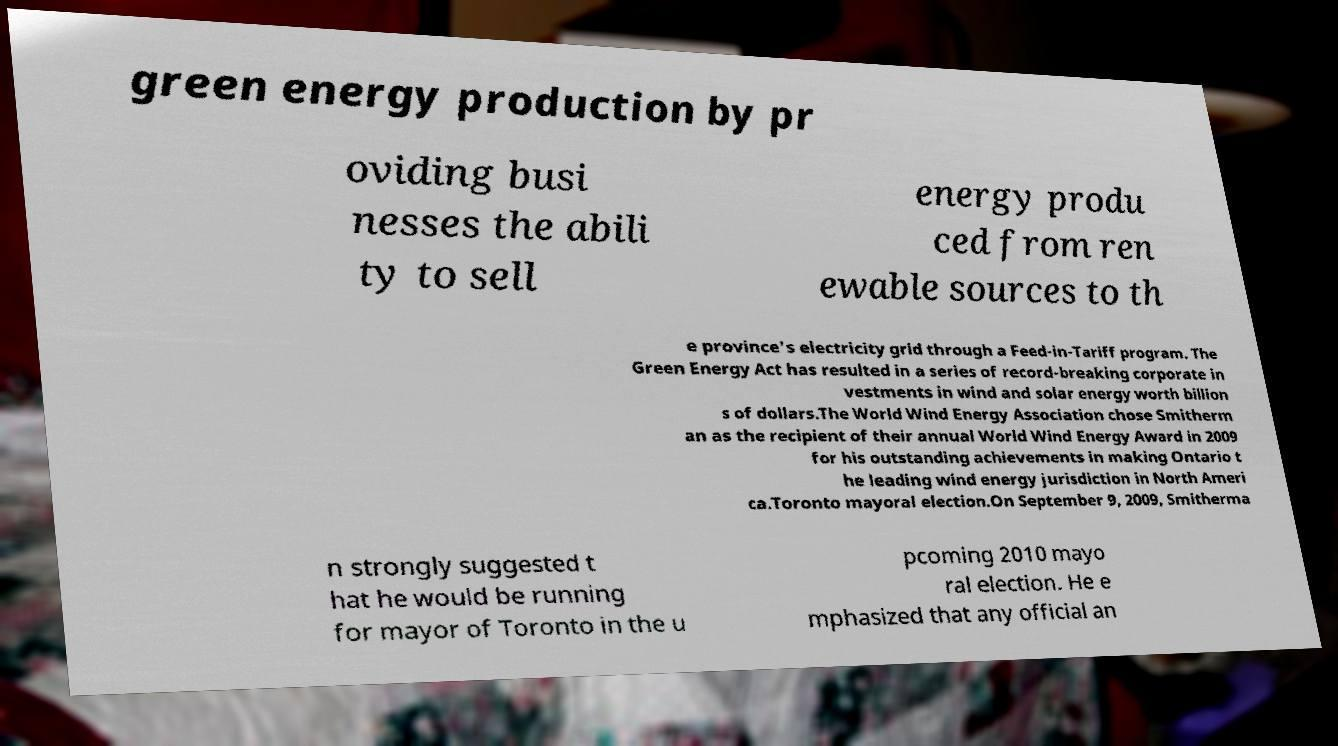Could you assist in decoding the text presented in this image and type it out clearly? green energy production by pr oviding busi nesses the abili ty to sell energy produ ced from ren ewable sources to th e province's electricity grid through a Feed-in-Tariff program. The Green Energy Act has resulted in a series of record-breaking corporate in vestments in wind and solar energy worth billion s of dollars.The World Wind Energy Association chose Smitherm an as the recipient of their annual World Wind Energy Award in 2009 for his outstanding achievements in making Ontario t he leading wind energy jurisdiction in North Ameri ca.Toronto mayoral election.On September 9, 2009, Smitherma n strongly suggested t hat he would be running for mayor of Toronto in the u pcoming 2010 mayo ral election. He e mphasized that any official an 